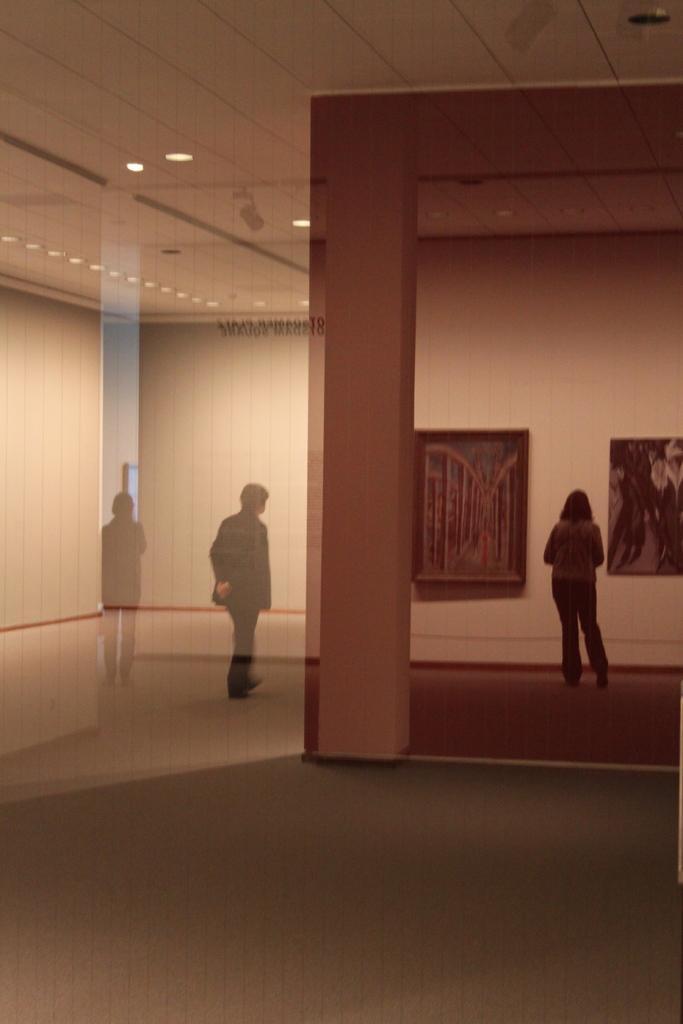Could you give a brief overview of what you see in this image? In this picture we can see an inside view of a building, three people standing on the floor, walls, frames, ceiling, lights and some objects. 